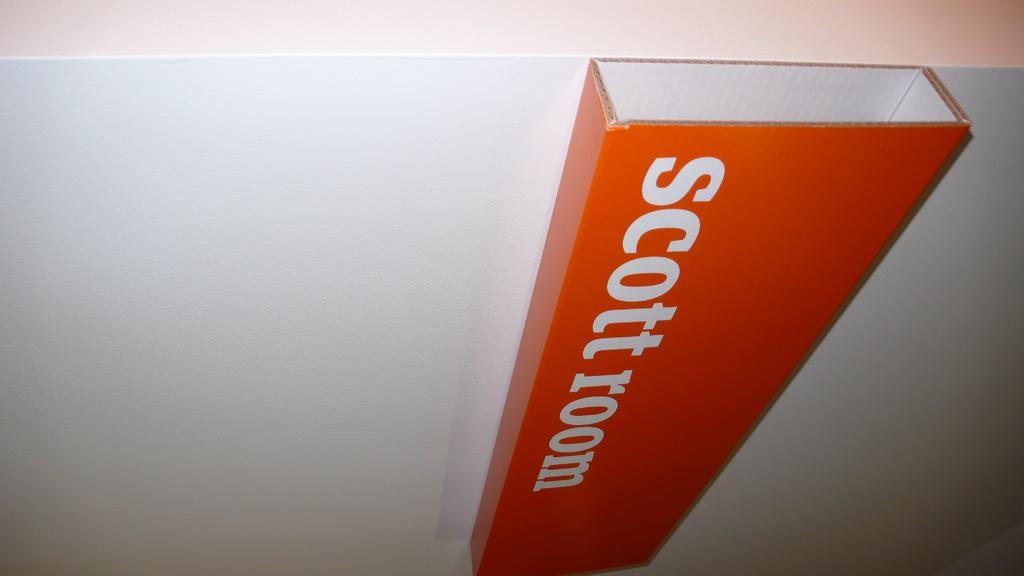Provide a one-sentence caption for the provided image. A rectangular box of cardboard reading Scott room is glued or otherwise attached to a white wall or piece of cardboard. 